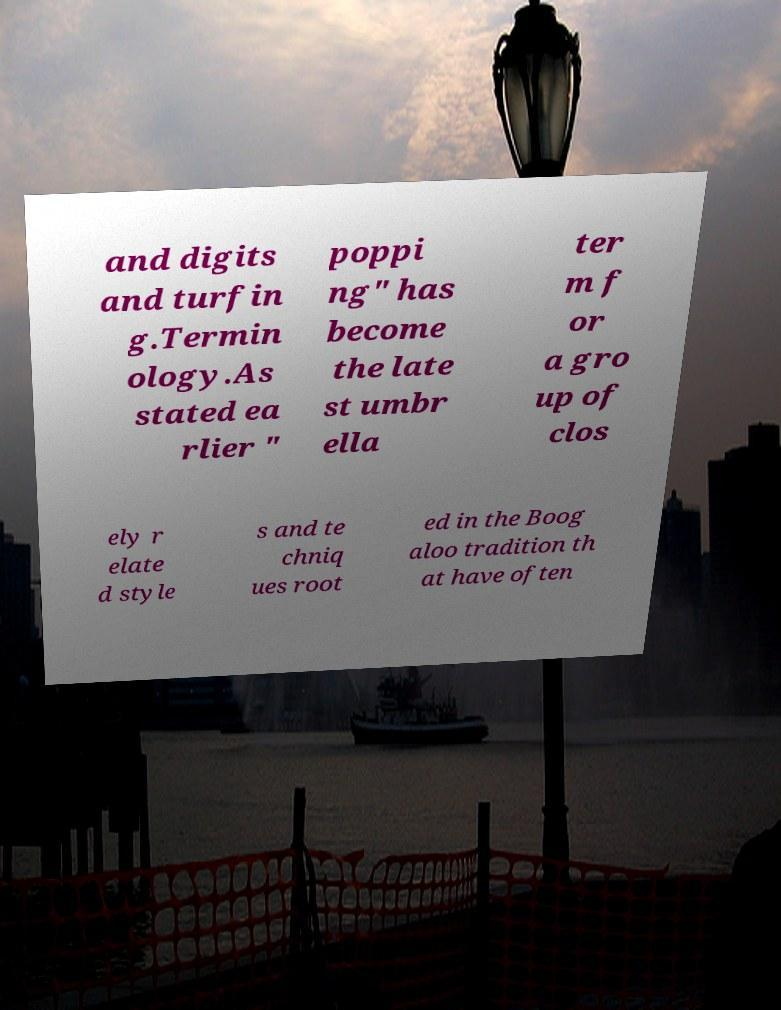Can you accurately transcribe the text from the provided image for me? and digits and turfin g.Termin ology.As stated ea rlier " poppi ng" has become the late st umbr ella ter m f or a gro up of clos ely r elate d style s and te chniq ues root ed in the Boog aloo tradition th at have often 